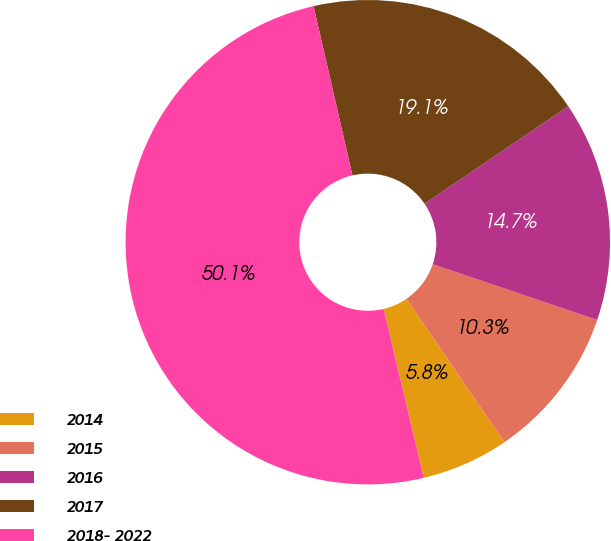Convert chart. <chart><loc_0><loc_0><loc_500><loc_500><pie_chart><fcel>2014<fcel>2015<fcel>2016<fcel>2017<fcel>2018- 2022<nl><fcel>5.83%<fcel>10.26%<fcel>14.69%<fcel>19.11%<fcel>50.12%<nl></chart> 